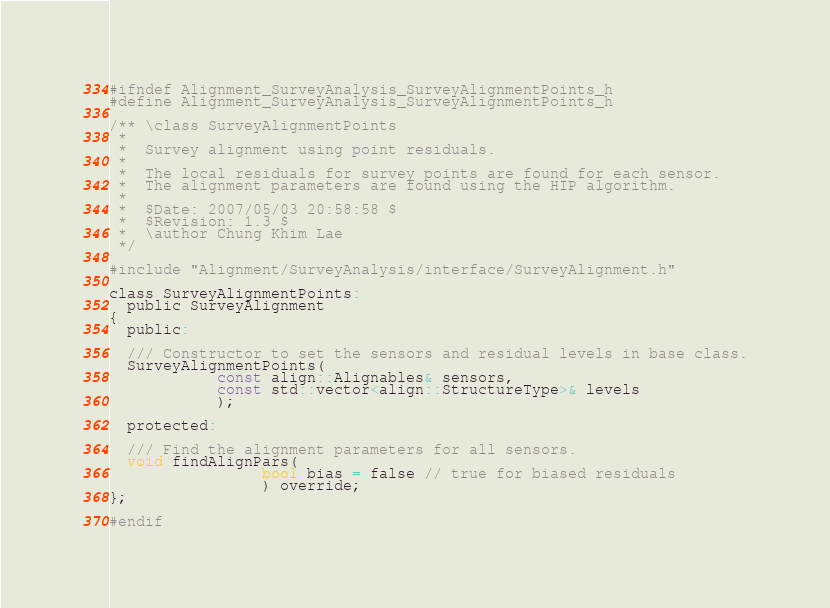Convert code to text. <code><loc_0><loc_0><loc_500><loc_500><_C_>#ifndef Alignment_SurveyAnalysis_SurveyAlignmentPoints_h
#define Alignment_SurveyAnalysis_SurveyAlignmentPoints_h

/** \class SurveyAlignmentPoints
 *
 *  Survey alignment using point residuals.
 *
 *  The local residuals for survey points are found for each sensor.
 *  The alignment parameters are found using the HIP algorithm.
 *
 *  $Date: 2007/05/03 20:58:58 $
 *  $Revision: 1.3 $
 *  \author Chung Khim Lae
 */

#include "Alignment/SurveyAnalysis/interface/SurveyAlignment.h"

class SurveyAlignmentPoints:
  public SurveyAlignment
{
  public:

  /// Constructor to set the sensors and residual levels in base class.
  SurveyAlignmentPoints(
			const align::Alignables& sensors,
			const std::vector<align::StructureType>& levels
			);

  protected:

  /// Find the alignment parameters for all sensors.
  void findAlignPars(
			     bool bias = false // true for biased residuals
			     ) override;
};

#endif
</code> 